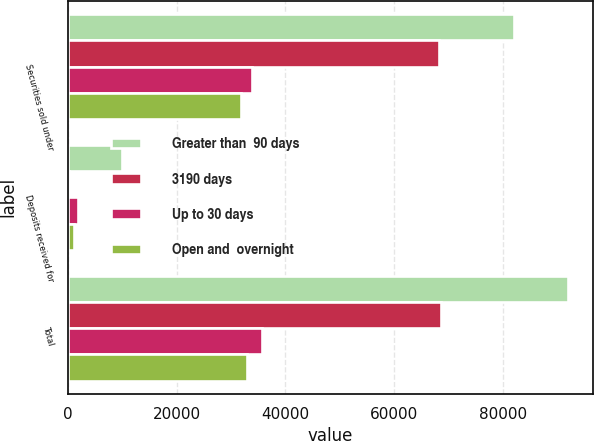Convert chart. <chart><loc_0><loc_0><loc_500><loc_500><stacked_bar_chart><ecel><fcel>Securities sold under<fcel>Deposits received for<fcel>Total<nl><fcel>Greater than  90 days<fcel>82073<fcel>9946<fcel>92019<nl><fcel>3190 days<fcel>68372<fcel>266<fcel>68638<nl><fcel>Up to 30 days<fcel>33846<fcel>1912<fcel>35758<nl><fcel>Open and  overnight<fcel>31831<fcel>1181<fcel>33012<nl></chart> 